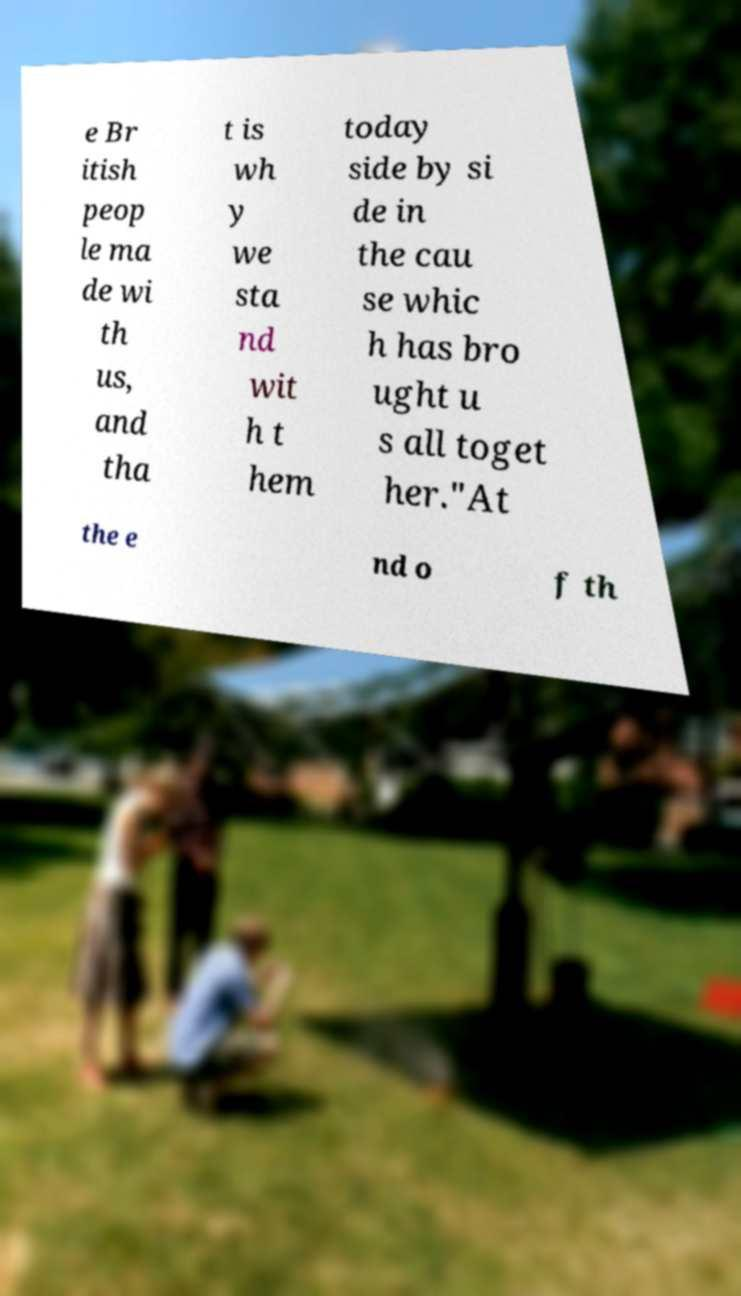Could you assist in decoding the text presented in this image and type it out clearly? e Br itish peop le ma de wi th us, and tha t is wh y we sta nd wit h t hem today side by si de in the cau se whic h has bro ught u s all toget her."At the e nd o f th 